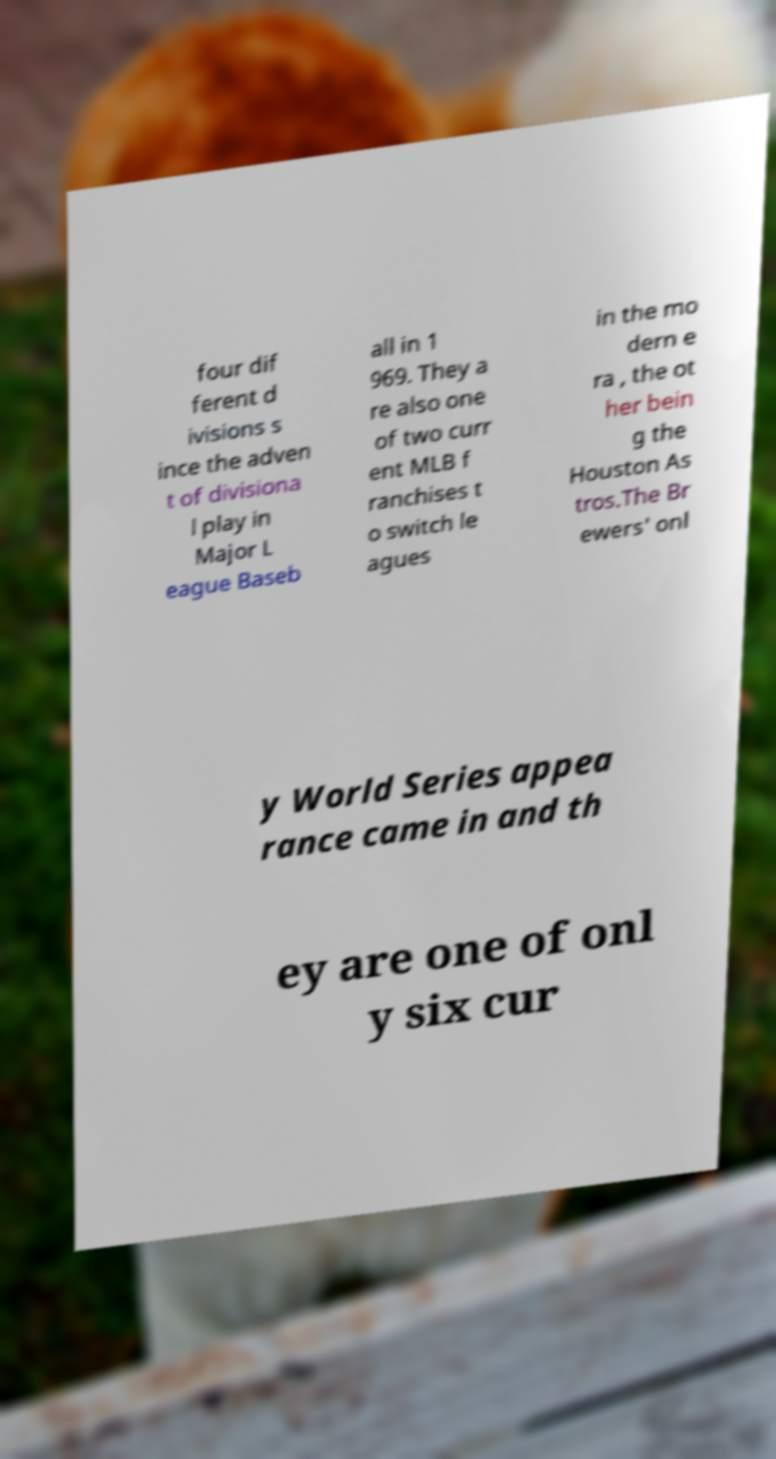Please identify and transcribe the text found in this image. four dif ferent d ivisions s ince the adven t of divisiona l play in Major L eague Baseb all in 1 969. They a re also one of two curr ent MLB f ranchises t o switch le agues in the mo dern e ra , the ot her bein g the Houston As tros.The Br ewers' onl y World Series appea rance came in and th ey are one of onl y six cur 